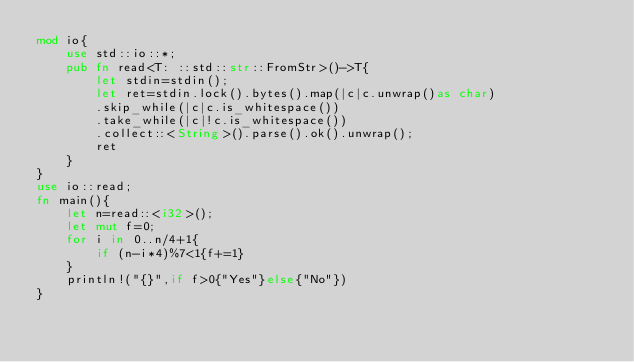Convert code to text. <code><loc_0><loc_0><loc_500><loc_500><_Rust_>mod io{
    use std::io::*;
    pub fn read<T: ::std::str::FromStr>()->T{
        let stdin=stdin();
        let ret=stdin.lock().bytes().map(|c|c.unwrap()as char)
        .skip_while(|c|c.is_whitespace())
        .take_while(|c|!c.is_whitespace())
        .collect::<String>().parse().ok().unwrap();
        ret
    }
}
use io::read;
fn main(){
    let n=read::<i32>();
    let mut f=0;
    for i in 0..n/4+1{
        if (n-i*4)%7<1{f+=1}
    }
    println!("{}",if f>0{"Yes"}else{"No"})
}
</code> 